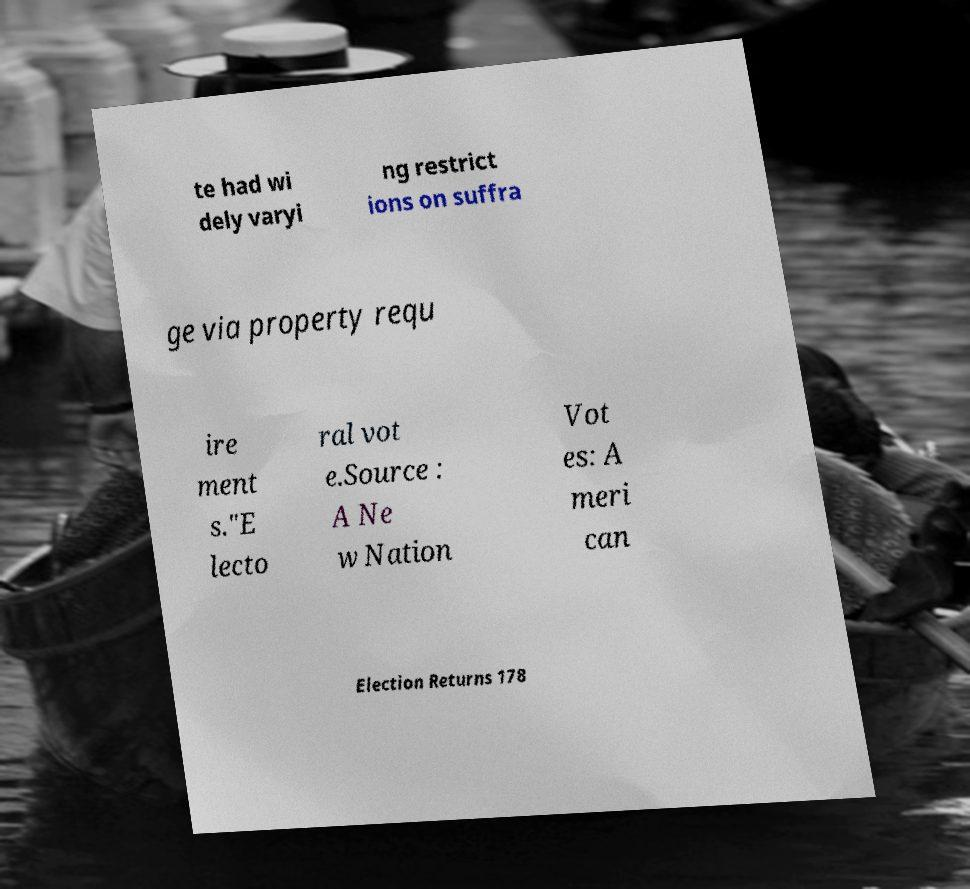Please read and relay the text visible in this image. What does it say? te had wi dely varyi ng restrict ions on suffra ge via property requ ire ment s."E lecto ral vot e.Source : A Ne w Nation Vot es: A meri can Election Returns 178 